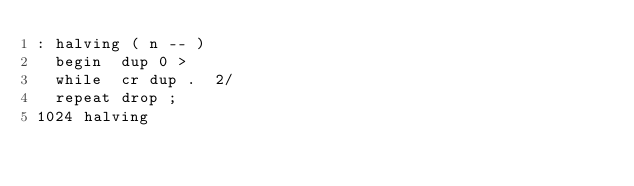Convert code to text. <code><loc_0><loc_0><loc_500><loc_500><_Forth_>: halving ( n -- )
  begin  dup 0 >
  while  cr dup .  2/
  repeat drop ;
1024 halving
</code> 